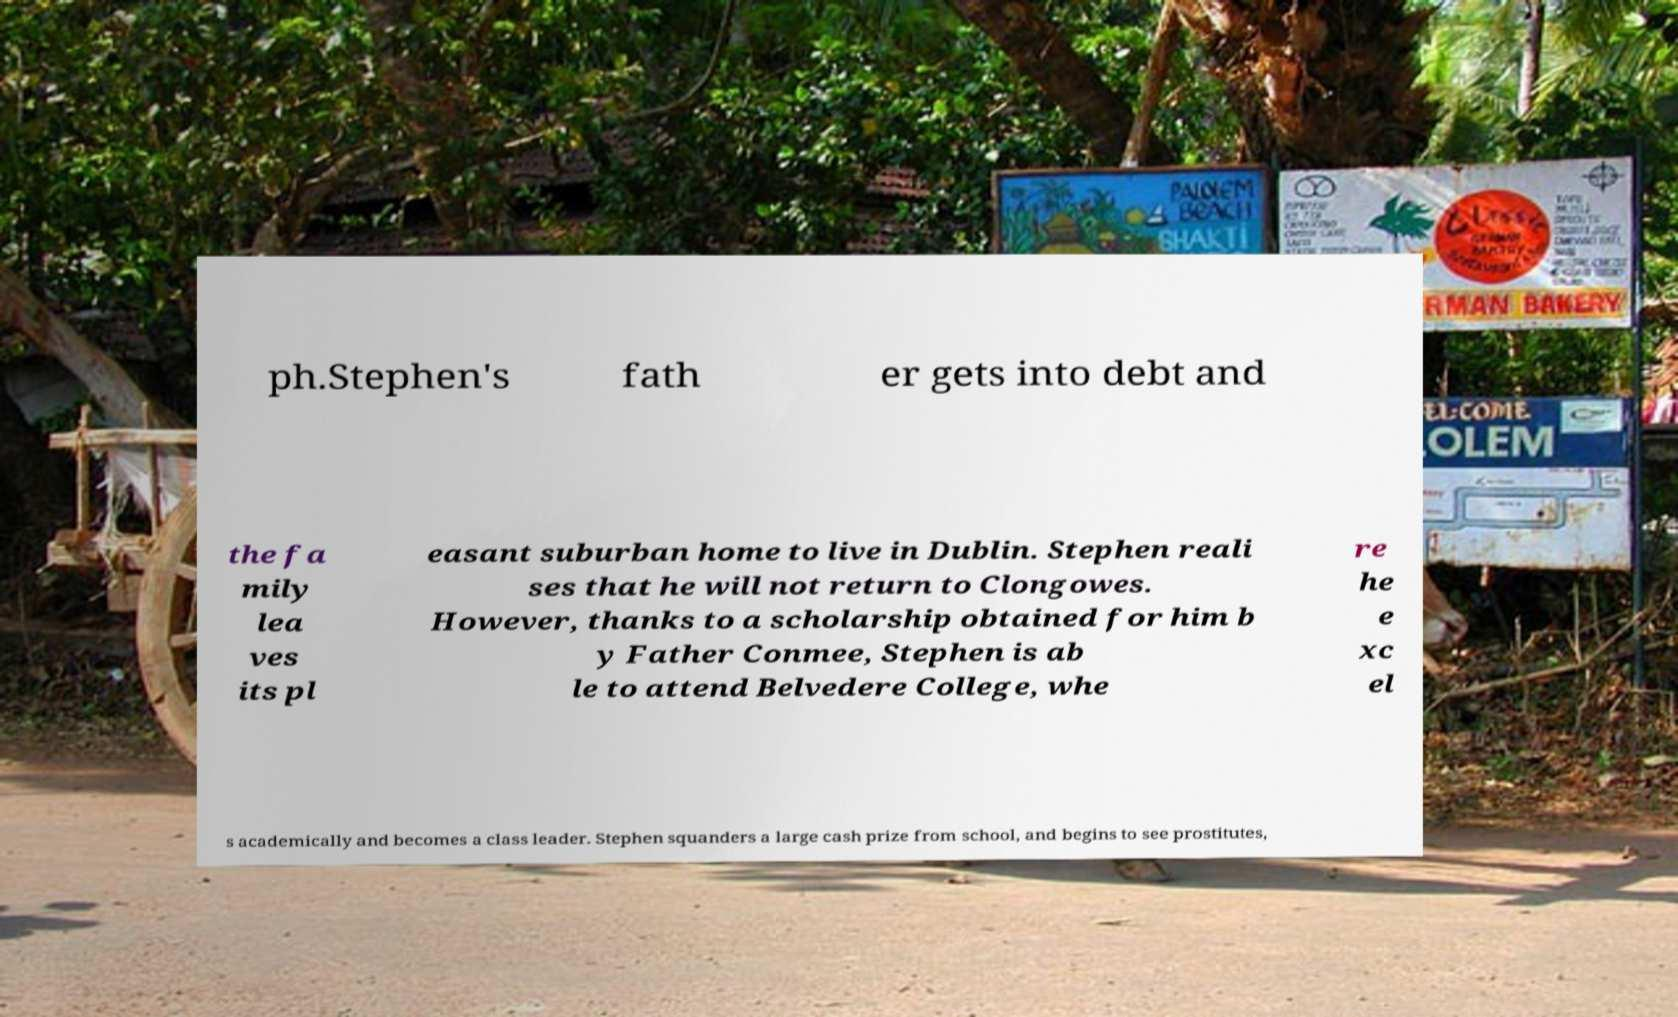I need the written content from this picture converted into text. Can you do that? ph.Stephen's fath er gets into debt and the fa mily lea ves its pl easant suburban home to live in Dublin. Stephen reali ses that he will not return to Clongowes. However, thanks to a scholarship obtained for him b y Father Conmee, Stephen is ab le to attend Belvedere College, whe re he e xc el s academically and becomes a class leader. Stephen squanders a large cash prize from school, and begins to see prostitutes, 